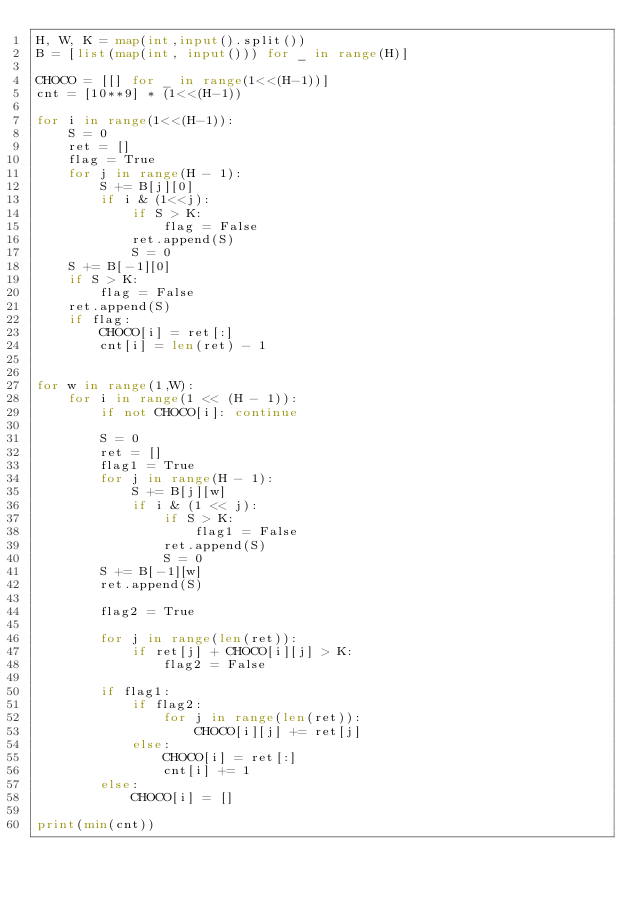<code> <loc_0><loc_0><loc_500><loc_500><_Python_>H, W, K = map(int,input().split())
B = [list(map(int, input())) for _ in range(H)]

CHOCO = [[] for _ in range(1<<(H-1))]
cnt = [10**9] * (1<<(H-1))

for i in range(1<<(H-1)):
    S = 0
    ret = []
    flag = True
    for j in range(H - 1):
        S += B[j][0]
        if i & (1<<j):
            if S > K:
                flag = False
            ret.append(S)
            S = 0
    S += B[-1][0]
    if S > K:
        flag = False
    ret.append(S)
    if flag:
        CHOCO[i] = ret[:]
        cnt[i] = len(ret) - 1


for w in range(1,W):
    for i in range(1 << (H - 1)):
        if not CHOCO[i]: continue

        S = 0
        ret = []
        flag1 = True
        for j in range(H - 1):
            S += B[j][w]
            if i & (1 << j):
                if S > K:
                    flag1 = False
                ret.append(S)
                S = 0
        S += B[-1][w]
        ret.append(S)

        flag2 = True

        for j in range(len(ret)):
            if ret[j] + CHOCO[i][j] > K:
                flag2 = False

        if flag1:
            if flag2:
                for j in range(len(ret)):
                    CHOCO[i][j] += ret[j]
            else:
                CHOCO[i] = ret[:]
                cnt[i] += 1
        else:
            CHOCO[i] = []

print(min(cnt))</code> 